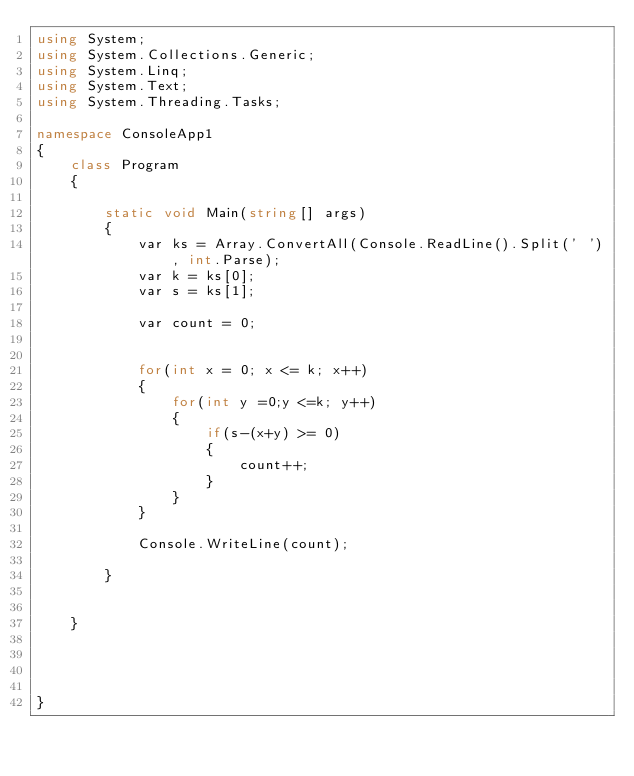Convert code to text. <code><loc_0><loc_0><loc_500><loc_500><_C#_>using System;
using System.Collections.Generic;
using System.Linq;
using System.Text;
using System.Threading.Tasks;

namespace ConsoleApp1
{
    class Program
    {

        static void Main(string[] args)
        {
            var ks = Array.ConvertAll(Console.ReadLine().Split(' '), int.Parse);
            var k = ks[0];
            var s = ks[1];

            var count = 0;
            

            for(int x = 0; x <= k; x++)
            {
                for(int y =0;y <=k; y++)
                {
                    if(s-(x+y) >= 0)
                    {
                        count++;
                    }
                }
            }

            Console.WriteLine(count);

        }
        

    }
    

    

}
</code> 